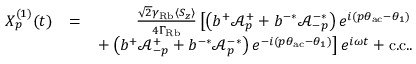Convert formula to latex. <formula><loc_0><loc_0><loc_500><loc_500>\begin{array} { r l r } { X _ { p } ^ { ( 1 ) } ( t ) } & { = } & { \frac { \sqrt { 2 } \gamma _ { R b } \langle S _ { z } \rangle } { 4 \Gamma _ { R b } } \left [ \left ( b ^ { + } \mathcal { A } _ { p } ^ { + } + b ^ { - * } \mathcal { A } _ { - p } ^ { - * } \right ) e ^ { i ( p \theta _ { a c } - \theta _ { 1 } ) } } \\ & { + \left ( b ^ { + } \mathcal { A } _ { - p } ^ { + } + b ^ { - * } \mathcal { A } _ { p } ^ { - * } \right ) e ^ { - i ( p \theta _ { a c } - \theta _ { 1 } ) } \right ] e ^ { i \omega t } + c . c . . } \end{array}</formula> 